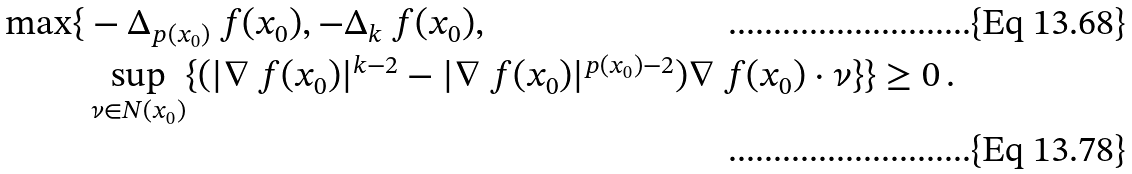Convert formula to latex. <formula><loc_0><loc_0><loc_500><loc_500>\max \{ & - \Delta _ { p ( x _ { 0 } ) } \ f ( x _ { 0 } ) , - \Delta _ { k } \ f ( x _ { 0 } ) , \\ & \sup _ { \nu \in N ( x _ { 0 } ) } \{ ( | \nabla \ f ( x _ { 0 } ) | ^ { k - 2 } - | \nabla \ f ( x _ { 0 } ) | ^ { p ( x _ { 0 } ) - 2 } ) \nabla \ f ( x _ { 0 } ) \cdot \nu \} \} \geq 0 \, .</formula> 